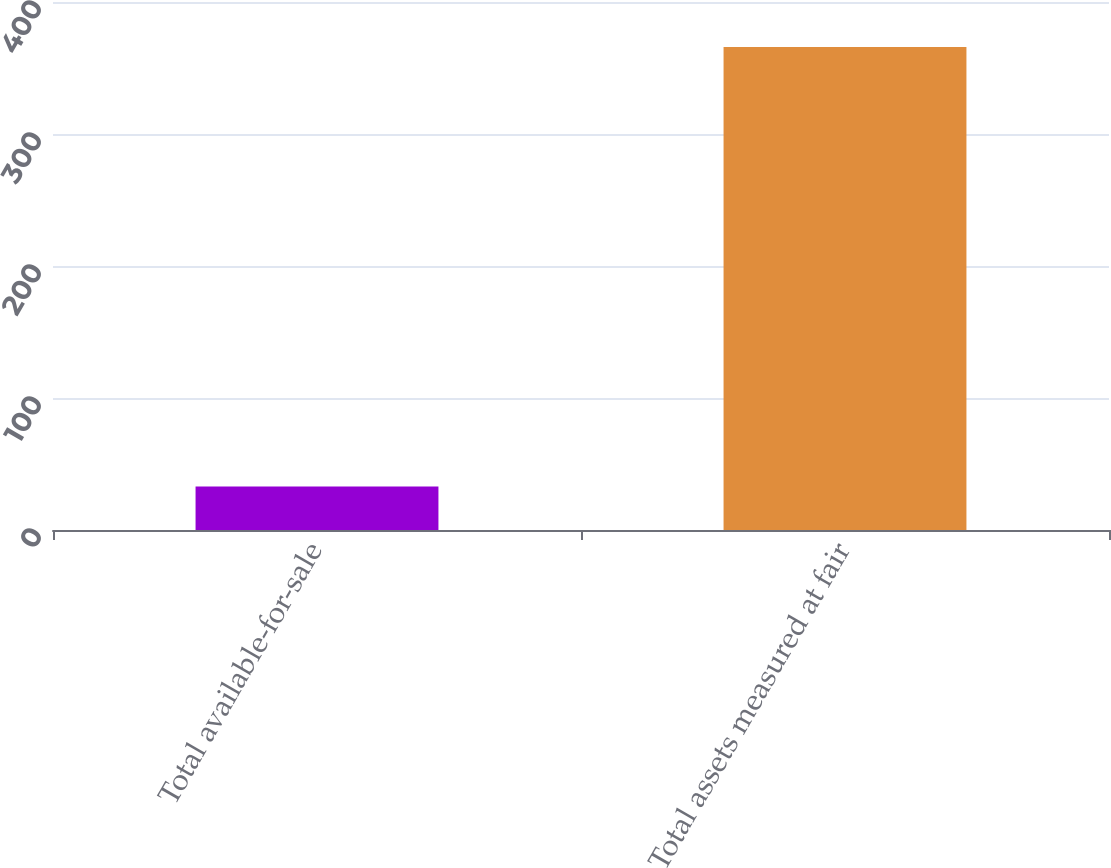Convert chart to OTSL. <chart><loc_0><loc_0><loc_500><loc_500><bar_chart><fcel>Total available-for-sale<fcel>Total assets measured at fair<nl><fcel>33<fcel>366<nl></chart> 